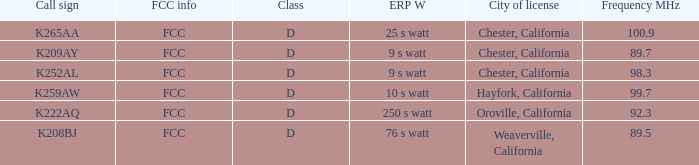Name the call sign with frequency of 89.5 K208BJ. 